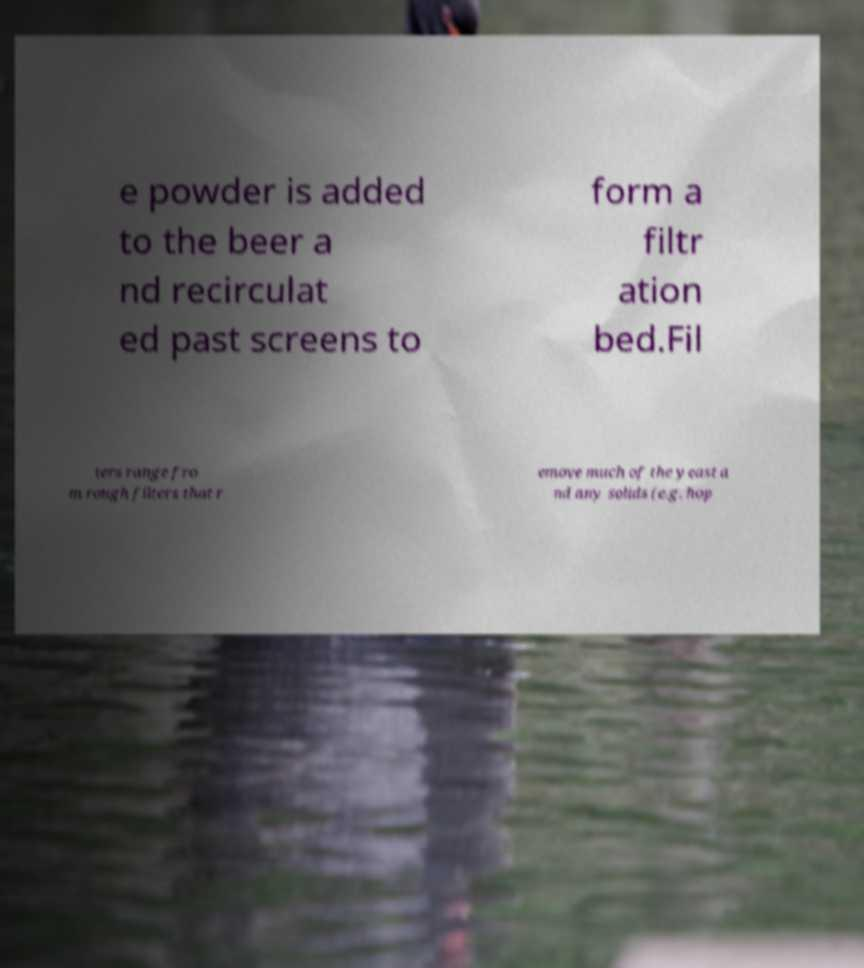There's text embedded in this image that I need extracted. Can you transcribe it verbatim? e powder is added to the beer a nd recirculat ed past screens to form a filtr ation bed.Fil ters range fro m rough filters that r emove much of the yeast a nd any solids (e.g. hop 